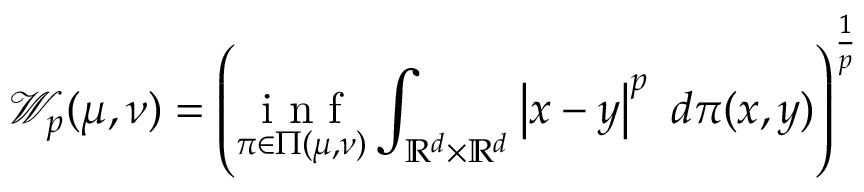<formula> <loc_0><loc_0><loc_500><loc_500>\mathcal { W } _ { p } ( \mu , \nu ) = \left ( \underset { \pi \in \Pi ( \mu , \nu ) } { i n f } \int _ { \mathbb { R } ^ { d } \times \mathbb { R } ^ { d } } \left | x - y \right | ^ { p } \ d \pi ( x , y ) \right ) ^ { \frac { 1 } { p } }</formula> 